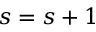<formula> <loc_0><loc_0><loc_500><loc_500>s = s + 1</formula> 